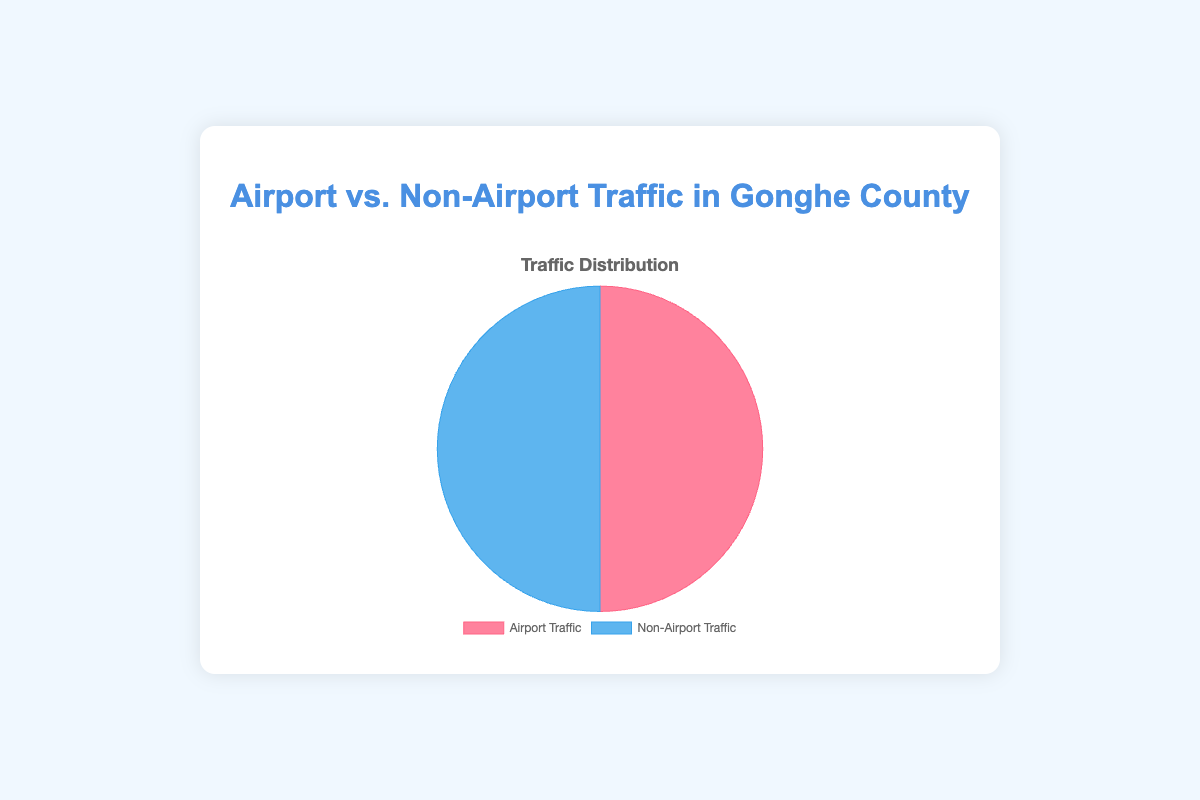Which type of traffic has a higher percentage in the overall traffic? The pie chart shows two colors representing 'Airport Traffic' and 'Non-Airport Traffic'. As both sections are equal in size, they each have a share of 50% in the total traffic.
Answer: Both are equal What is the total percentage of domestic and international flights within the airport traffic? The PIE chart does not show detailed categories, but knowing the data details: Domestic Flights is 35%, and International Flights is 25%. The sum is 35% + 25% = 60%.
Answer: 60% How does public transportation compare between airport and non-airport traffic? Referring to the provided category data: 'Public Transportation' is exclusively in 'Non-Airport Traffic' with 10%. 'Airport Traffic' has no specific public transportation category.
Answer: Exclusive to Non-Airport What is the visual difference in the colors representing airport and non-airport traffic? The figure uses colors to differentiate, with 'Airport Traffic' represented in pinkish-red and 'Non-Airport Traffic' in blue.
Answer: Pinkish-red and Blue If airport traffic grows by 20%, what percentage will it contribute then? Currently, 'Airport Traffic' is 50%. An increase by 20% of 50 leads to a new total contribution of 50% + 10% = 60%.
Answer: 60% Which has a higher percentage of miscellaneous sources: airport or non-airport traffic? Miscellaneous for airport traffic is 5%, while non-airport traffic also has 5%. Both are equal in this category.
Answer: Both are equal How do local residents' commute percentages compare to airport staff commute? 'Local Residents Commute' is part of non-airport traffic at 40%, and 'Airport Staff Commute' within airport traffic is 10%. 40% is greater than 10%.
Answer: Local Residents Commute is higher What's the combined percentage of cargo transport in both traffic types? 'Cargo Transport' in airport traffic is 15%, and 'Freight and Cargo Transport' in non-airport traffic is 5%. Combined: 15% + 5% = 20%.
Answer: 20% Which section is larger visually, the one representing domestic flights in airport traffic or tourist visits in non-airport traffic? The data details show 'Domestic Flights' within airport traffic as 35%, while 'Tourist Visits' in non-airport traffic is 20%. Visually, 35% is represented larger than 20%.
Answer: Domestic Flights 